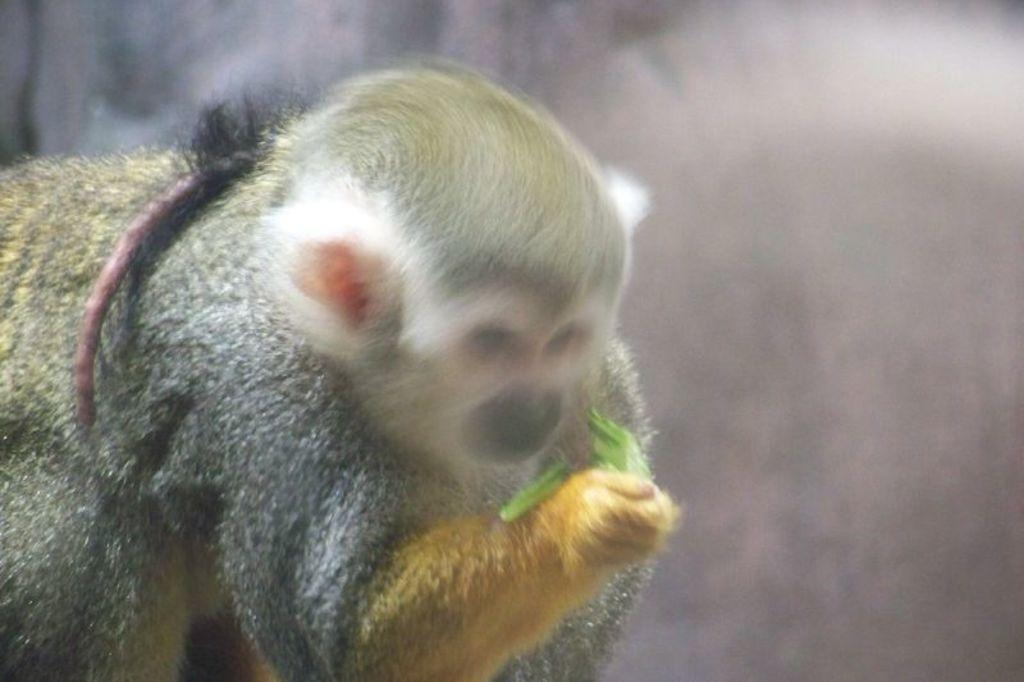What animal is present in the image? There is a monkey in the image. How would you describe the quality of the background in the image? The background of the image is blurred. What is the monkey holding in its hand? The monkey is holding something in its hand, but the specific object cannot be determined from the provided facts. What is the name of the basketball player in the image? There is no basketball player present in the image, only a monkey. What type of account does the monkey have in the image? There is no mention of an account in the image, as it features a monkey holding an unspecified object. 